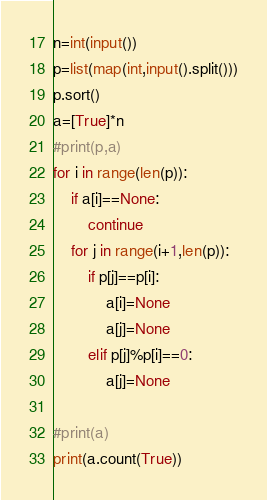<code> <loc_0><loc_0><loc_500><loc_500><_Python_>n=int(input())
p=list(map(int,input().split()))
p.sort()
a=[True]*n
#print(p,a)
for i in range(len(p)):
    if a[i]==None:
        continue
    for j in range(i+1,len(p)):
        if p[j]==p[i]:
            a[i]=None
            a[j]=None
        elif p[j]%p[i]==0:
            a[j]=None

#print(a)
print(a.count(True))</code> 